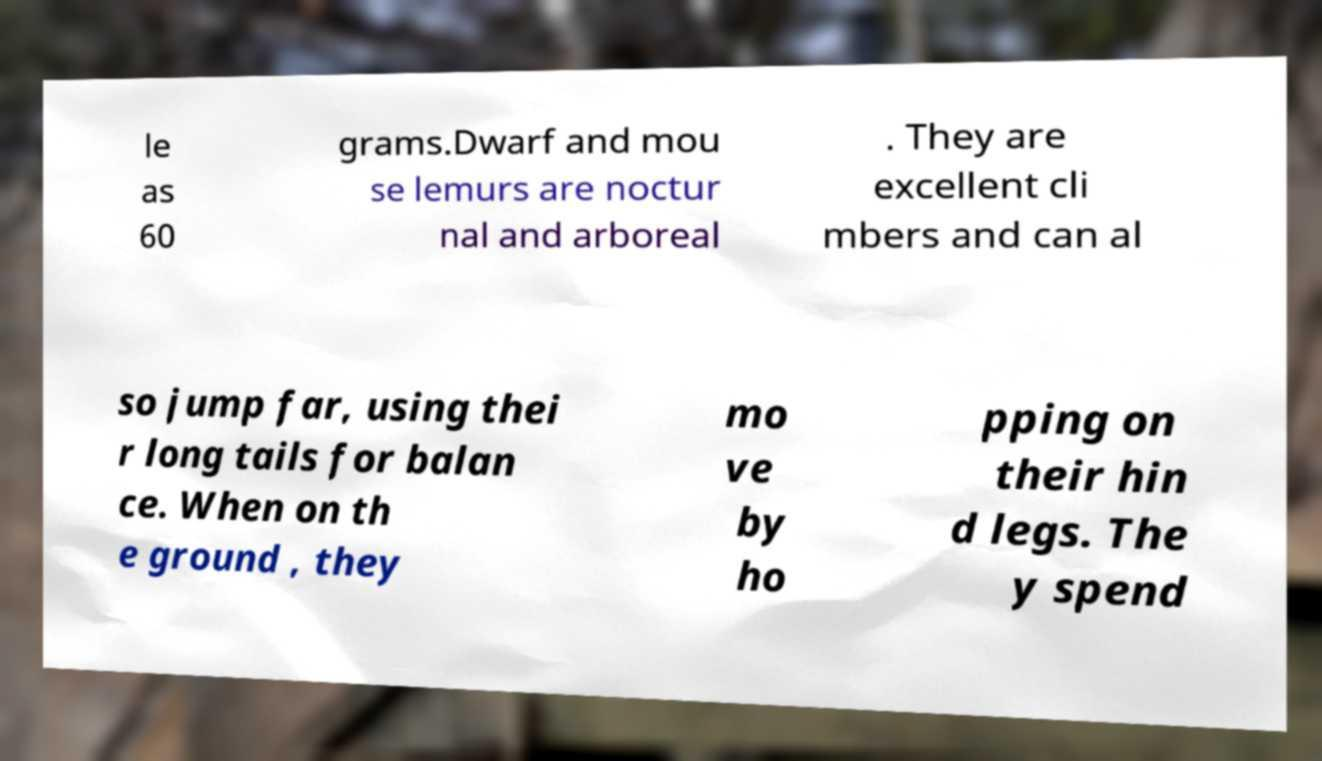There's text embedded in this image that I need extracted. Can you transcribe it verbatim? le as 60 grams.Dwarf and mou se lemurs are noctur nal and arboreal . They are excellent cli mbers and can al so jump far, using thei r long tails for balan ce. When on th e ground , they mo ve by ho pping on their hin d legs. The y spend 